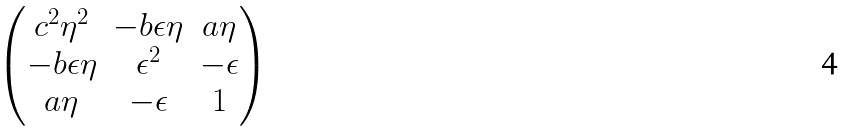<formula> <loc_0><loc_0><loc_500><loc_500>\begin{pmatrix} c ^ { 2 } \eta ^ { 2 } & - b \epsilon \eta & a \eta \\ - b \epsilon \eta & \epsilon ^ { 2 } & - \epsilon \\ a \eta & - \epsilon & 1 \end{pmatrix}</formula> 